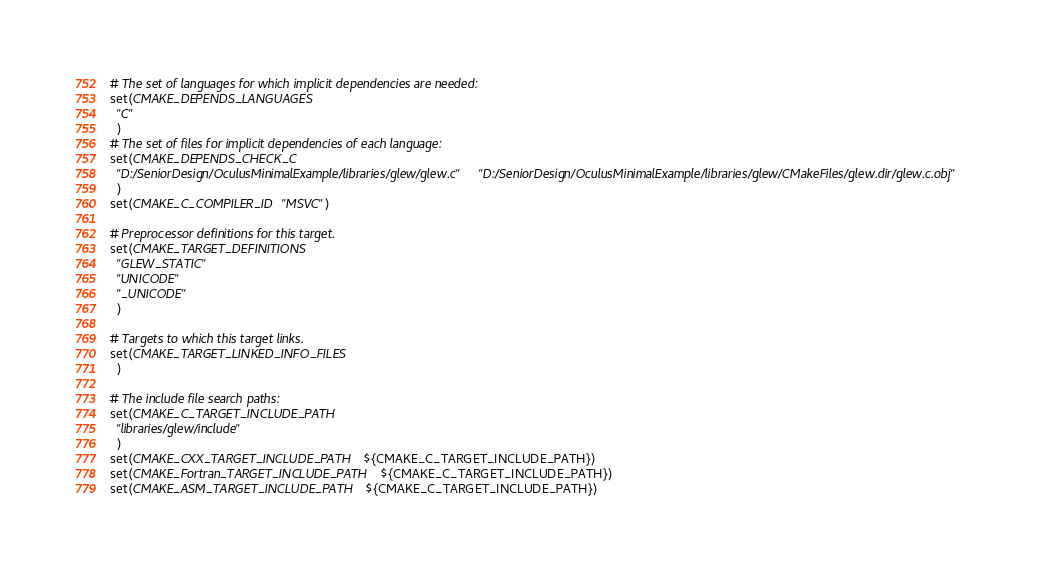<code> <loc_0><loc_0><loc_500><loc_500><_CMake_># The set of languages for which implicit dependencies are needed:
set(CMAKE_DEPENDS_LANGUAGES
  "C"
  )
# The set of files for implicit dependencies of each language:
set(CMAKE_DEPENDS_CHECK_C
  "D:/SeniorDesign/OculusMinimalExample/libraries/glew/glew.c" "D:/SeniorDesign/OculusMinimalExample/libraries/glew/CMakeFiles/glew.dir/glew.c.obj"
  )
set(CMAKE_C_COMPILER_ID "MSVC")

# Preprocessor definitions for this target.
set(CMAKE_TARGET_DEFINITIONS
  "GLEW_STATIC"
  "UNICODE"
  "_UNICODE"
  )

# Targets to which this target links.
set(CMAKE_TARGET_LINKED_INFO_FILES
  )

# The include file search paths:
set(CMAKE_C_TARGET_INCLUDE_PATH
  "libraries/glew/include"
  )
set(CMAKE_CXX_TARGET_INCLUDE_PATH ${CMAKE_C_TARGET_INCLUDE_PATH})
set(CMAKE_Fortran_TARGET_INCLUDE_PATH ${CMAKE_C_TARGET_INCLUDE_PATH})
set(CMAKE_ASM_TARGET_INCLUDE_PATH ${CMAKE_C_TARGET_INCLUDE_PATH})
</code> 